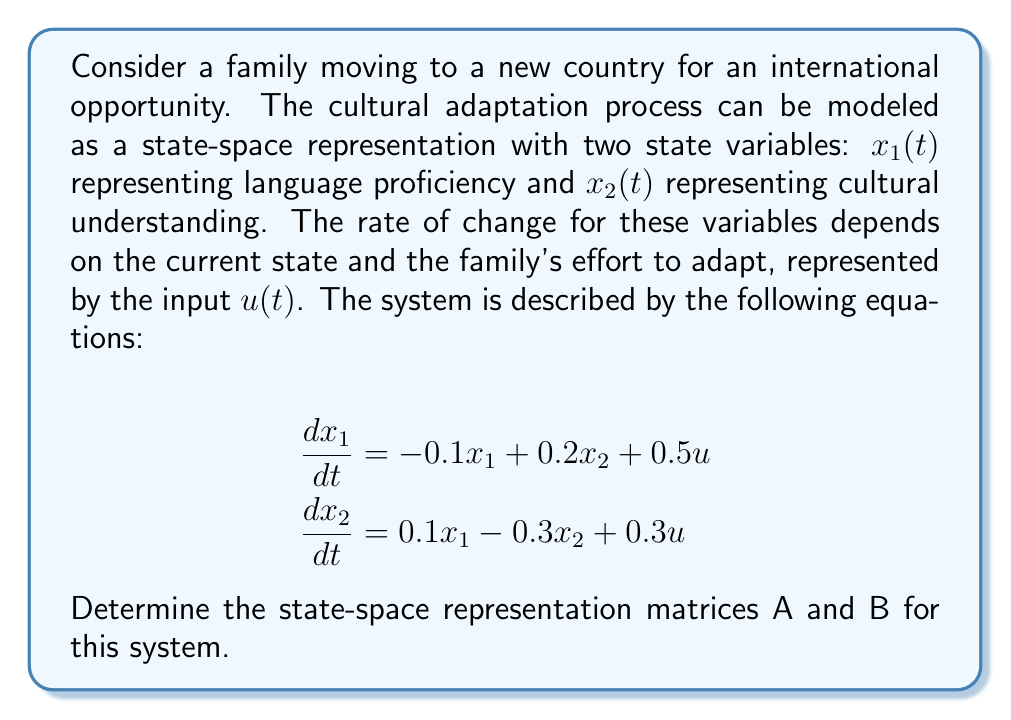Help me with this question. To determine the state-space representation matrices A and B, we need to rewrite the system in the standard form:

$$\frac{d\mathbf{x}}{dt} = A\mathbf{x} + B\mathbf{u}$$

Where $\mathbf{x}$ is the state vector, $\mathbf{u}$ is the input vector, A is the system matrix, and B is the input matrix.

Given equations:
$$\frac{dx_1}{dt} = -0.1x_1 + 0.2x_2 + 0.5u$$
$$\frac{dx_2}{dt} = 0.1x_1 - 0.3x_2 + 0.3u$$

Step 1: Identify the state vector $\mathbf{x}$
$$\mathbf{x} = \begin{bmatrix} x_1 \\ x_2 \end{bmatrix}$$

Step 2: Identify the input vector $\mathbf{u}$
$$\mathbf{u} = [u]$$

Step 3: Determine matrix A by collecting the coefficients of $x_1$ and $x_2$
$$A = \begin{bmatrix} 
-0.1 & 0.2 \\
0.1 & -0.3
\end{bmatrix}$$

Step 4: Determine matrix B by collecting the coefficients of $u$
$$B = \begin{bmatrix}
0.5 \\
0.3
\end{bmatrix}$$

Therefore, the state-space representation of the cultural adaptation system is:

$$\frac{d}{dt}\begin{bmatrix} x_1 \\ x_2 \end{bmatrix} = 
\begin{bmatrix} 
-0.1 & 0.2 \\
0.1 & -0.3
\end{bmatrix}\begin{bmatrix} x_1 \\ x_2 \end{bmatrix} + 
\begin{bmatrix}
0.5 \\
0.3
\end{bmatrix}u$$
Answer: A = $\begin{bmatrix} 
-0.1 & 0.2 \\
0.1 & -0.3
\end{bmatrix}$, B = $\begin{bmatrix}
0.5 \\
0.3
\end{bmatrix}$ 